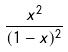Convert formula to latex. <formula><loc_0><loc_0><loc_500><loc_500>\frac { x ^ { 2 } } { ( 1 - x ) ^ { 2 } }</formula> 